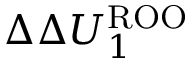<formula> <loc_0><loc_0><loc_500><loc_500>\Delta \Delta U _ { 1 } ^ { R O O }</formula> 